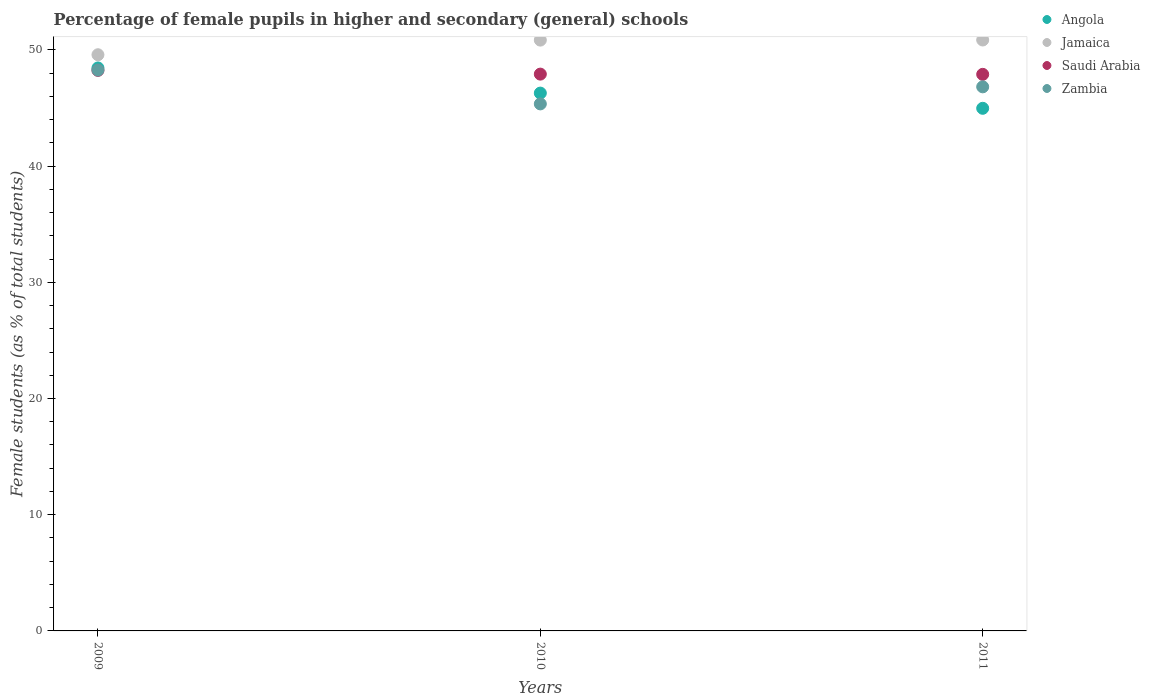Is the number of dotlines equal to the number of legend labels?
Offer a terse response. Yes. What is the percentage of female pupils in higher and secondary schools in Zambia in 2009?
Provide a succinct answer. 48.26. Across all years, what is the maximum percentage of female pupils in higher and secondary schools in Jamaica?
Your response must be concise. 50.85. Across all years, what is the minimum percentage of female pupils in higher and secondary schools in Saudi Arabia?
Your answer should be very brief. 47.89. In which year was the percentage of female pupils in higher and secondary schools in Jamaica maximum?
Your answer should be very brief. 2011. What is the total percentage of female pupils in higher and secondary schools in Zambia in the graph?
Your response must be concise. 140.43. What is the difference between the percentage of female pupils in higher and secondary schools in Zambia in 2009 and that in 2011?
Offer a very short reply. 1.44. What is the difference between the percentage of female pupils in higher and secondary schools in Angola in 2009 and the percentage of female pupils in higher and secondary schools in Saudi Arabia in 2010?
Offer a terse response. 0.53. What is the average percentage of female pupils in higher and secondary schools in Zambia per year?
Provide a short and direct response. 46.81. In the year 2009, what is the difference between the percentage of female pupils in higher and secondary schools in Angola and percentage of female pupils in higher and secondary schools in Zambia?
Provide a short and direct response. 0.18. In how many years, is the percentage of female pupils in higher and secondary schools in Jamaica greater than 16 %?
Make the answer very short. 3. What is the ratio of the percentage of female pupils in higher and secondary schools in Angola in 2009 to that in 2010?
Offer a very short reply. 1.05. What is the difference between the highest and the second highest percentage of female pupils in higher and secondary schools in Angola?
Your response must be concise. 2.17. What is the difference between the highest and the lowest percentage of female pupils in higher and secondary schools in Saudi Arabia?
Ensure brevity in your answer.  0.34. In how many years, is the percentage of female pupils in higher and secondary schools in Jamaica greater than the average percentage of female pupils in higher and secondary schools in Jamaica taken over all years?
Ensure brevity in your answer.  2. Is it the case that in every year, the sum of the percentage of female pupils in higher and secondary schools in Zambia and percentage of female pupils in higher and secondary schools in Saudi Arabia  is greater than the sum of percentage of female pupils in higher and secondary schools in Angola and percentage of female pupils in higher and secondary schools in Jamaica?
Offer a very short reply. Yes. Is it the case that in every year, the sum of the percentage of female pupils in higher and secondary schools in Angola and percentage of female pupils in higher and secondary schools in Jamaica  is greater than the percentage of female pupils in higher and secondary schools in Zambia?
Ensure brevity in your answer.  Yes. Does the percentage of female pupils in higher and secondary schools in Saudi Arabia monotonically increase over the years?
Offer a terse response. No. What is the difference between two consecutive major ticks on the Y-axis?
Provide a succinct answer. 10. Are the values on the major ticks of Y-axis written in scientific E-notation?
Provide a succinct answer. No. Does the graph contain grids?
Your answer should be compact. No. How many legend labels are there?
Offer a terse response. 4. What is the title of the graph?
Your response must be concise. Percentage of female pupils in higher and secondary (general) schools. Does "Hong Kong" appear as one of the legend labels in the graph?
Ensure brevity in your answer.  No. What is the label or title of the Y-axis?
Offer a terse response. Female students (as % of total students). What is the Female students (as % of total students) of Angola in 2009?
Offer a very short reply. 48.44. What is the Female students (as % of total students) of Jamaica in 2009?
Provide a succinct answer. 49.58. What is the Female students (as % of total students) in Saudi Arabia in 2009?
Offer a terse response. 48.23. What is the Female students (as % of total students) of Zambia in 2009?
Your answer should be very brief. 48.26. What is the Female students (as % of total students) of Angola in 2010?
Your response must be concise. 46.28. What is the Female students (as % of total students) in Jamaica in 2010?
Make the answer very short. 50.84. What is the Female students (as % of total students) in Saudi Arabia in 2010?
Provide a short and direct response. 47.91. What is the Female students (as % of total students) of Zambia in 2010?
Offer a terse response. 45.35. What is the Female students (as % of total students) in Angola in 2011?
Your answer should be compact. 44.97. What is the Female students (as % of total students) in Jamaica in 2011?
Offer a terse response. 50.85. What is the Female students (as % of total students) in Saudi Arabia in 2011?
Make the answer very short. 47.89. What is the Female students (as % of total students) of Zambia in 2011?
Keep it short and to the point. 46.82. Across all years, what is the maximum Female students (as % of total students) in Angola?
Offer a very short reply. 48.44. Across all years, what is the maximum Female students (as % of total students) of Jamaica?
Provide a succinct answer. 50.85. Across all years, what is the maximum Female students (as % of total students) in Saudi Arabia?
Make the answer very short. 48.23. Across all years, what is the maximum Female students (as % of total students) in Zambia?
Give a very brief answer. 48.26. Across all years, what is the minimum Female students (as % of total students) of Angola?
Offer a very short reply. 44.97. Across all years, what is the minimum Female students (as % of total students) of Jamaica?
Provide a short and direct response. 49.58. Across all years, what is the minimum Female students (as % of total students) of Saudi Arabia?
Make the answer very short. 47.89. Across all years, what is the minimum Female students (as % of total students) in Zambia?
Your answer should be compact. 45.35. What is the total Female students (as % of total students) in Angola in the graph?
Your answer should be very brief. 139.69. What is the total Female students (as % of total students) in Jamaica in the graph?
Your answer should be compact. 151.27. What is the total Female students (as % of total students) in Saudi Arabia in the graph?
Give a very brief answer. 144.04. What is the total Female students (as % of total students) of Zambia in the graph?
Offer a very short reply. 140.43. What is the difference between the Female students (as % of total students) in Angola in 2009 and that in 2010?
Provide a succinct answer. 2.17. What is the difference between the Female students (as % of total students) in Jamaica in 2009 and that in 2010?
Provide a succinct answer. -1.26. What is the difference between the Female students (as % of total students) in Saudi Arabia in 2009 and that in 2010?
Provide a short and direct response. 0.32. What is the difference between the Female students (as % of total students) of Zambia in 2009 and that in 2010?
Give a very brief answer. 2.91. What is the difference between the Female students (as % of total students) of Angola in 2009 and that in 2011?
Offer a terse response. 3.47. What is the difference between the Female students (as % of total students) of Jamaica in 2009 and that in 2011?
Your answer should be compact. -1.27. What is the difference between the Female students (as % of total students) of Saudi Arabia in 2009 and that in 2011?
Keep it short and to the point. 0.34. What is the difference between the Female students (as % of total students) of Zambia in 2009 and that in 2011?
Give a very brief answer. 1.44. What is the difference between the Female students (as % of total students) of Angola in 2010 and that in 2011?
Ensure brevity in your answer.  1.31. What is the difference between the Female students (as % of total students) in Jamaica in 2010 and that in 2011?
Give a very brief answer. -0.01. What is the difference between the Female students (as % of total students) in Saudi Arabia in 2010 and that in 2011?
Give a very brief answer. 0.02. What is the difference between the Female students (as % of total students) in Zambia in 2010 and that in 2011?
Keep it short and to the point. -1.47. What is the difference between the Female students (as % of total students) of Angola in 2009 and the Female students (as % of total students) of Jamaica in 2010?
Give a very brief answer. -2.4. What is the difference between the Female students (as % of total students) of Angola in 2009 and the Female students (as % of total students) of Saudi Arabia in 2010?
Give a very brief answer. 0.53. What is the difference between the Female students (as % of total students) of Angola in 2009 and the Female students (as % of total students) of Zambia in 2010?
Offer a terse response. 3.09. What is the difference between the Female students (as % of total students) in Jamaica in 2009 and the Female students (as % of total students) in Saudi Arabia in 2010?
Your answer should be very brief. 1.67. What is the difference between the Female students (as % of total students) in Jamaica in 2009 and the Female students (as % of total students) in Zambia in 2010?
Provide a succinct answer. 4.23. What is the difference between the Female students (as % of total students) of Saudi Arabia in 2009 and the Female students (as % of total students) of Zambia in 2010?
Provide a short and direct response. 2.88. What is the difference between the Female students (as % of total students) of Angola in 2009 and the Female students (as % of total students) of Jamaica in 2011?
Your answer should be compact. -2.4. What is the difference between the Female students (as % of total students) in Angola in 2009 and the Female students (as % of total students) in Saudi Arabia in 2011?
Give a very brief answer. 0.55. What is the difference between the Female students (as % of total students) of Angola in 2009 and the Female students (as % of total students) of Zambia in 2011?
Your response must be concise. 1.63. What is the difference between the Female students (as % of total students) in Jamaica in 2009 and the Female students (as % of total students) in Saudi Arabia in 2011?
Your answer should be very brief. 1.69. What is the difference between the Female students (as % of total students) of Jamaica in 2009 and the Female students (as % of total students) of Zambia in 2011?
Provide a short and direct response. 2.76. What is the difference between the Female students (as % of total students) in Saudi Arabia in 2009 and the Female students (as % of total students) in Zambia in 2011?
Give a very brief answer. 1.41. What is the difference between the Female students (as % of total students) in Angola in 2010 and the Female students (as % of total students) in Jamaica in 2011?
Offer a very short reply. -4.57. What is the difference between the Female students (as % of total students) of Angola in 2010 and the Female students (as % of total students) of Saudi Arabia in 2011?
Give a very brief answer. -1.61. What is the difference between the Female students (as % of total students) of Angola in 2010 and the Female students (as % of total students) of Zambia in 2011?
Keep it short and to the point. -0.54. What is the difference between the Female students (as % of total students) of Jamaica in 2010 and the Female students (as % of total students) of Saudi Arabia in 2011?
Keep it short and to the point. 2.95. What is the difference between the Female students (as % of total students) in Jamaica in 2010 and the Female students (as % of total students) in Zambia in 2011?
Your response must be concise. 4.02. What is the difference between the Female students (as % of total students) in Saudi Arabia in 2010 and the Female students (as % of total students) in Zambia in 2011?
Keep it short and to the point. 1.09. What is the average Female students (as % of total students) of Angola per year?
Your answer should be compact. 46.56. What is the average Female students (as % of total students) of Jamaica per year?
Give a very brief answer. 50.42. What is the average Female students (as % of total students) in Saudi Arabia per year?
Ensure brevity in your answer.  48.01. What is the average Female students (as % of total students) in Zambia per year?
Your response must be concise. 46.81. In the year 2009, what is the difference between the Female students (as % of total students) of Angola and Female students (as % of total students) of Jamaica?
Provide a succinct answer. -1.14. In the year 2009, what is the difference between the Female students (as % of total students) of Angola and Female students (as % of total students) of Saudi Arabia?
Provide a succinct answer. 0.21. In the year 2009, what is the difference between the Female students (as % of total students) in Angola and Female students (as % of total students) in Zambia?
Offer a terse response. 0.18. In the year 2009, what is the difference between the Female students (as % of total students) of Jamaica and Female students (as % of total students) of Saudi Arabia?
Make the answer very short. 1.35. In the year 2009, what is the difference between the Female students (as % of total students) in Jamaica and Female students (as % of total students) in Zambia?
Provide a succinct answer. 1.32. In the year 2009, what is the difference between the Female students (as % of total students) in Saudi Arabia and Female students (as % of total students) in Zambia?
Offer a terse response. -0.03. In the year 2010, what is the difference between the Female students (as % of total students) of Angola and Female students (as % of total students) of Jamaica?
Make the answer very short. -4.56. In the year 2010, what is the difference between the Female students (as % of total students) in Angola and Female students (as % of total students) in Saudi Arabia?
Keep it short and to the point. -1.63. In the year 2010, what is the difference between the Female students (as % of total students) in Angola and Female students (as % of total students) in Zambia?
Provide a succinct answer. 0.93. In the year 2010, what is the difference between the Female students (as % of total students) in Jamaica and Female students (as % of total students) in Saudi Arabia?
Keep it short and to the point. 2.93. In the year 2010, what is the difference between the Female students (as % of total students) in Jamaica and Female students (as % of total students) in Zambia?
Ensure brevity in your answer.  5.49. In the year 2010, what is the difference between the Female students (as % of total students) in Saudi Arabia and Female students (as % of total students) in Zambia?
Your answer should be compact. 2.56. In the year 2011, what is the difference between the Female students (as % of total students) in Angola and Female students (as % of total students) in Jamaica?
Keep it short and to the point. -5.88. In the year 2011, what is the difference between the Female students (as % of total students) of Angola and Female students (as % of total students) of Saudi Arabia?
Provide a short and direct response. -2.92. In the year 2011, what is the difference between the Female students (as % of total students) in Angola and Female students (as % of total students) in Zambia?
Your answer should be very brief. -1.85. In the year 2011, what is the difference between the Female students (as % of total students) in Jamaica and Female students (as % of total students) in Saudi Arabia?
Your answer should be compact. 2.96. In the year 2011, what is the difference between the Female students (as % of total students) in Jamaica and Female students (as % of total students) in Zambia?
Your answer should be very brief. 4.03. In the year 2011, what is the difference between the Female students (as % of total students) in Saudi Arabia and Female students (as % of total students) in Zambia?
Your answer should be very brief. 1.07. What is the ratio of the Female students (as % of total students) in Angola in 2009 to that in 2010?
Provide a succinct answer. 1.05. What is the ratio of the Female students (as % of total students) in Jamaica in 2009 to that in 2010?
Ensure brevity in your answer.  0.98. What is the ratio of the Female students (as % of total students) of Saudi Arabia in 2009 to that in 2010?
Provide a succinct answer. 1.01. What is the ratio of the Female students (as % of total students) of Zambia in 2009 to that in 2010?
Your answer should be very brief. 1.06. What is the ratio of the Female students (as % of total students) in Angola in 2009 to that in 2011?
Provide a short and direct response. 1.08. What is the ratio of the Female students (as % of total students) in Saudi Arabia in 2009 to that in 2011?
Offer a very short reply. 1.01. What is the ratio of the Female students (as % of total students) in Zambia in 2009 to that in 2011?
Offer a very short reply. 1.03. What is the ratio of the Female students (as % of total students) of Angola in 2010 to that in 2011?
Give a very brief answer. 1.03. What is the ratio of the Female students (as % of total students) of Saudi Arabia in 2010 to that in 2011?
Give a very brief answer. 1. What is the ratio of the Female students (as % of total students) of Zambia in 2010 to that in 2011?
Provide a short and direct response. 0.97. What is the difference between the highest and the second highest Female students (as % of total students) in Angola?
Keep it short and to the point. 2.17. What is the difference between the highest and the second highest Female students (as % of total students) in Jamaica?
Provide a short and direct response. 0.01. What is the difference between the highest and the second highest Female students (as % of total students) in Saudi Arabia?
Your answer should be compact. 0.32. What is the difference between the highest and the second highest Female students (as % of total students) in Zambia?
Ensure brevity in your answer.  1.44. What is the difference between the highest and the lowest Female students (as % of total students) in Angola?
Ensure brevity in your answer.  3.47. What is the difference between the highest and the lowest Female students (as % of total students) in Jamaica?
Make the answer very short. 1.27. What is the difference between the highest and the lowest Female students (as % of total students) in Saudi Arabia?
Keep it short and to the point. 0.34. What is the difference between the highest and the lowest Female students (as % of total students) in Zambia?
Make the answer very short. 2.91. 